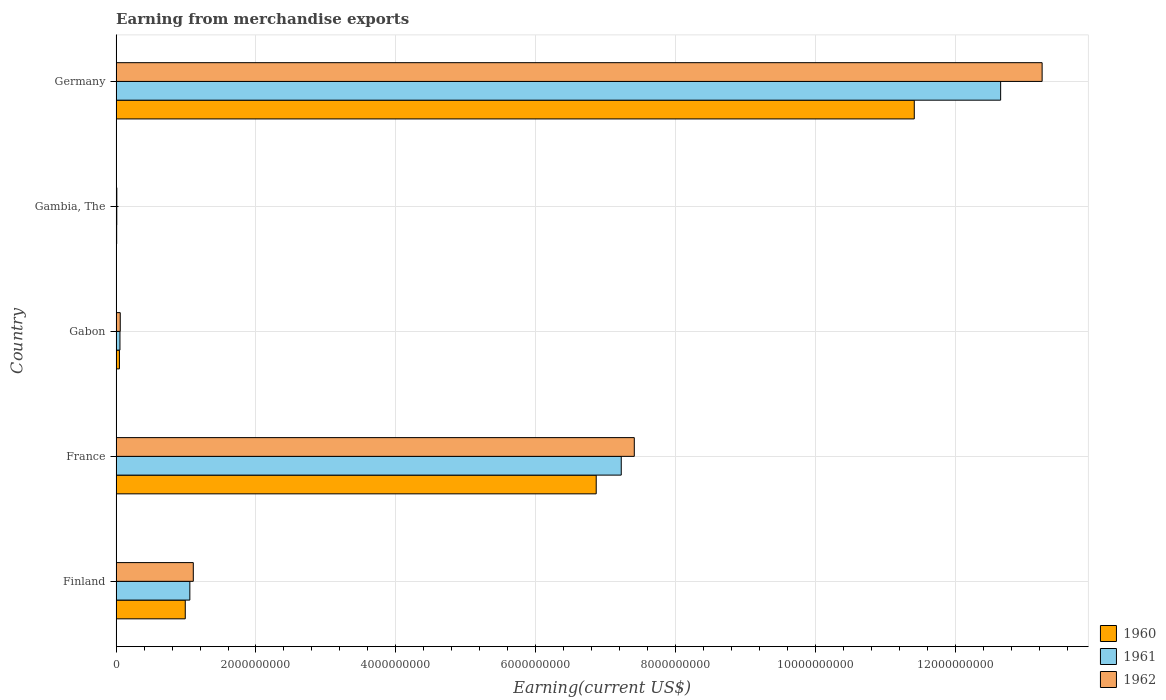What is the label of the 4th group of bars from the top?
Provide a short and direct response. France. In how many cases, is the number of bars for a given country not equal to the number of legend labels?
Ensure brevity in your answer.  0. What is the amount earned from merchandise exports in 1961 in France?
Your response must be concise. 7.22e+09. Across all countries, what is the maximum amount earned from merchandise exports in 1960?
Offer a very short reply. 1.14e+1. Across all countries, what is the minimum amount earned from merchandise exports in 1960?
Your response must be concise. 7.79e+06. In which country was the amount earned from merchandise exports in 1961 minimum?
Your answer should be compact. Gambia, The. What is the total amount earned from merchandise exports in 1961 in the graph?
Offer a terse response. 2.10e+1. What is the difference between the amount earned from merchandise exports in 1962 in Finland and that in France?
Your response must be concise. -6.31e+09. What is the difference between the amount earned from merchandise exports in 1960 in Gabon and the amount earned from merchandise exports in 1961 in Finland?
Ensure brevity in your answer.  -1.01e+09. What is the average amount earned from merchandise exports in 1961 per country?
Your answer should be very brief. 4.20e+09. What is the difference between the amount earned from merchandise exports in 1961 and amount earned from merchandise exports in 1960 in Gabon?
Provide a succinct answer. 7.33e+06. What is the ratio of the amount earned from merchandise exports in 1962 in Finland to that in Gabon?
Your response must be concise. 18.74. Is the amount earned from merchandise exports in 1961 in Gabon less than that in Germany?
Your answer should be compact. Yes. Is the difference between the amount earned from merchandise exports in 1961 in Gambia, The and Germany greater than the difference between the amount earned from merchandise exports in 1960 in Gambia, The and Germany?
Provide a short and direct response. No. What is the difference between the highest and the second highest amount earned from merchandise exports in 1961?
Provide a succinct answer. 5.43e+09. What is the difference between the highest and the lowest amount earned from merchandise exports in 1961?
Ensure brevity in your answer.  1.26e+1. In how many countries, is the amount earned from merchandise exports in 1962 greater than the average amount earned from merchandise exports in 1962 taken over all countries?
Give a very brief answer. 2. What does the 1st bar from the bottom in France represents?
Ensure brevity in your answer.  1960. Are all the bars in the graph horizontal?
Ensure brevity in your answer.  Yes. How many countries are there in the graph?
Offer a very short reply. 5. Are the values on the major ticks of X-axis written in scientific E-notation?
Make the answer very short. No. Does the graph contain grids?
Offer a very short reply. Yes. How are the legend labels stacked?
Your response must be concise. Vertical. What is the title of the graph?
Give a very brief answer. Earning from merchandise exports. Does "2005" appear as one of the legend labels in the graph?
Provide a succinct answer. No. What is the label or title of the X-axis?
Offer a terse response. Earning(current US$). What is the Earning(current US$) in 1960 in Finland?
Ensure brevity in your answer.  9.89e+08. What is the Earning(current US$) in 1961 in Finland?
Keep it short and to the point. 1.05e+09. What is the Earning(current US$) of 1962 in Finland?
Your response must be concise. 1.10e+09. What is the Earning(current US$) in 1960 in France?
Offer a very short reply. 6.87e+09. What is the Earning(current US$) in 1961 in France?
Provide a short and direct response. 7.22e+09. What is the Earning(current US$) of 1962 in France?
Offer a terse response. 7.41e+09. What is the Earning(current US$) of 1960 in Gabon?
Your answer should be compact. 4.74e+07. What is the Earning(current US$) of 1961 in Gabon?
Your answer should be compact. 5.47e+07. What is the Earning(current US$) of 1962 in Gabon?
Your response must be concise. 5.89e+07. What is the Earning(current US$) in 1960 in Gambia, The?
Your answer should be compact. 7.79e+06. What is the Earning(current US$) in 1961 in Gambia, The?
Provide a short and direct response. 9.45e+06. What is the Earning(current US$) in 1962 in Gambia, The?
Keep it short and to the point. 9.99e+06. What is the Earning(current US$) in 1960 in Germany?
Provide a succinct answer. 1.14e+1. What is the Earning(current US$) in 1961 in Germany?
Your answer should be very brief. 1.27e+1. What is the Earning(current US$) of 1962 in Germany?
Your answer should be compact. 1.32e+1. Across all countries, what is the maximum Earning(current US$) of 1960?
Offer a very short reply. 1.14e+1. Across all countries, what is the maximum Earning(current US$) of 1961?
Your answer should be very brief. 1.27e+1. Across all countries, what is the maximum Earning(current US$) of 1962?
Your answer should be very brief. 1.32e+1. Across all countries, what is the minimum Earning(current US$) of 1960?
Your answer should be very brief. 7.79e+06. Across all countries, what is the minimum Earning(current US$) of 1961?
Offer a terse response. 9.45e+06. Across all countries, what is the minimum Earning(current US$) in 1962?
Provide a succinct answer. 9.99e+06. What is the total Earning(current US$) of 1960 in the graph?
Ensure brevity in your answer.  1.93e+1. What is the total Earning(current US$) of 1961 in the graph?
Keep it short and to the point. 2.10e+1. What is the total Earning(current US$) in 1962 in the graph?
Give a very brief answer. 2.18e+1. What is the difference between the Earning(current US$) in 1960 in Finland and that in France?
Your answer should be very brief. -5.88e+09. What is the difference between the Earning(current US$) in 1961 in Finland and that in France?
Offer a very short reply. -6.17e+09. What is the difference between the Earning(current US$) of 1962 in Finland and that in France?
Ensure brevity in your answer.  -6.31e+09. What is the difference between the Earning(current US$) of 1960 in Finland and that in Gabon?
Make the answer very short. 9.41e+08. What is the difference between the Earning(current US$) of 1961 in Finland and that in Gabon?
Your answer should be very brief. 1.00e+09. What is the difference between the Earning(current US$) of 1962 in Finland and that in Gabon?
Your answer should be very brief. 1.04e+09. What is the difference between the Earning(current US$) of 1960 in Finland and that in Gambia, The?
Your answer should be compact. 9.81e+08. What is the difference between the Earning(current US$) of 1961 in Finland and that in Gambia, The?
Your answer should be very brief. 1.04e+09. What is the difference between the Earning(current US$) in 1962 in Finland and that in Gambia, The?
Ensure brevity in your answer.  1.09e+09. What is the difference between the Earning(current US$) of 1960 in Finland and that in Germany?
Give a very brief answer. -1.04e+1. What is the difference between the Earning(current US$) in 1961 in Finland and that in Germany?
Give a very brief answer. -1.16e+1. What is the difference between the Earning(current US$) in 1962 in Finland and that in Germany?
Keep it short and to the point. -1.21e+1. What is the difference between the Earning(current US$) of 1960 in France and that in Gabon?
Your response must be concise. 6.82e+09. What is the difference between the Earning(current US$) of 1961 in France and that in Gabon?
Your answer should be very brief. 7.17e+09. What is the difference between the Earning(current US$) of 1962 in France and that in Gabon?
Provide a short and direct response. 7.35e+09. What is the difference between the Earning(current US$) of 1960 in France and that in Gambia, The?
Make the answer very short. 6.86e+09. What is the difference between the Earning(current US$) in 1961 in France and that in Gambia, The?
Your answer should be compact. 7.21e+09. What is the difference between the Earning(current US$) in 1962 in France and that in Gambia, The?
Make the answer very short. 7.40e+09. What is the difference between the Earning(current US$) in 1960 in France and that in Germany?
Your answer should be compact. -4.55e+09. What is the difference between the Earning(current US$) of 1961 in France and that in Germany?
Ensure brevity in your answer.  -5.43e+09. What is the difference between the Earning(current US$) in 1962 in France and that in Germany?
Make the answer very short. -5.83e+09. What is the difference between the Earning(current US$) in 1960 in Gabon and that in Gambia, The?
Provide a short and direct response. 3.96e+07. What is the difference between the Earning(current US$) in 1961 in Gabon and that in Gambia, The?
Keep it short and to the point. 4.52e+07. What is the difference between the Earning(current US$) of 1962 in Gabon and that in Gambia, The?
Offer a terse response. 4.89e+07. What is the difference between the Earning(current US$) in 1960 in Gabon and that in Germany?
Provide a short and direct response. -1.14e+1. What is the difference between the Earning(current US$) in 1961 in Gabon and that in Germany?
Keep it short and to the point. -1.26e+1. What is the difference between the Earning(current US$) of 1962 in Gabon and that in Germany?
Make the answer very short. -1.32e+1. What is the difference between the Earning(current US$) in 1960 in Gambia, The and that in Germany?
Your response must be concise. -1.14e+1. What is the difference between the Earning(current US$) of 1961 in Gambia, The and that in Germany?
Offer a very short reply. -1.26e+1. What is the difference between the Earning(current US$) in 1962 in Gambia, The and that in Germany?
Provide a short and direct response. -1.32e+1. What is the difference between the Earning(current US$) of 1960 in Finland and the Earning(current US$) of 1961 in France?
Provide a short and direct response. -6.24e+09. What is the difference between the Earning(current US$) of 1960 in Finland and the Earning(current US$) of 1962 in France?
Provide a short and direct response. -6.42e+09. What is the difference between the Earning(current US$) in 1961 in Finland and the Earning(current US$) in 1962 in France?
Provide a short and direct response. -6.36e+09. What is the difference between the Earning(current US$) in 1960 in Finland and the Earning(current US$) in 1961 in Gabon?
Provide a short and direct response. 9.34e+08. What is the difference between the Earning(current US$) in 1960 in Finland and the Earning(current US$) in 1962 in Gabon?
Your answer should be very brief. 9.30e+08. What is the difference between the Earning(current US$) of 1961 in Finland and the Earning(current US$) of 1962 in Gabon?
Offer a terse response. 9.95e+08. What is the difference between the Earning(current US$) of 1960 in Finland and the Earning(current US$) of 1961 in Gambia, The?
Give a very brief answer. 9.79e+08. What is the difference between the Earning(current US$) of 1960 in Finland and the Earning(current US$) of 1962 in Gambia, The?
Provide a short and direct response. 9.79e+08. What is the difference between the Earning(current US$) of 1961 in Finland and the Earning(current US$) of 1962 in Gambia, The?
Ensure brevity in your answer.  1.04e+09. What is the difference between the Earning(current US$) of 1960 in Finland and the Earning(current US$) of 1961 in Germany?
Make the answer very short. -1.17e+1. What is the difference between the Earning(current US$) of 1960 in Finland and the Earning(current US$) of 1962 in Germany?
Your answer should be very brief. -1.23e+1. What is the difference between the Earning(current US$) in 1961 in Finland and the Earning(current US$) in 1962 in Germany?
Provide a succinct answer. -1.22e+1. What is the difference between the Earning(current US$) in 1960 in France and the Earning(current US$) in 1961 in Gabon?
Your answer should be very brief. 6.81e+09. What is the difference between the Earning(current US$) in 1960 in France and the Earning(current US$) in 1962 in Gabon?
Give a very brief answer. 6.81e+09. What is the difference between the Earning(current US$) in 1961 in France and the Earning(current US$) in 1962 in Gabon?
Your answer should be compact. 7.17e+09. What is the difference between the Earning(current US$) of 1960 in France and the Earning(current US$) of 1961 in Gambia, The?
Ensure brevity in your answer.  6.86e+09. What is the difference between the Earning(current US$) of 1960 in France and the Earning(current US$) of 1962 in Gambia, The?
Your response must be concise. 6.86e+09. What is the difference between the Earning(current US$) of 1961 in France and the Earning(current US$) of 1962 in Gambia, The?
Give a very brief answer. 7.21e+09. What is the difference between the Earning(current US$) of 1960 in France and the Earning(current US$) of 1961 in Germany?
Offer a terse response. -5.78e+09. What is the difference between the Earning(current US$) of 1960 in France and the Earning(current US$) of 1962 in Germany?
Your answer should be compact. -6.38e+09. What is the difference between the Earning(current US$) in 1961 in France and the Earning(current US$) in 1962 in Germany?
Provide a succinct answer. -6.02e+09. What is the difference between the Earning(current US$) in 1960 in Gabon and the Earning(current US$) in 1961 in Gambia, The?
Your response must be concise. 3.79e+07. What is the difference between the Earning(current US$) of 1960 in Gabon and the Earning(current US$) of 1962 in Gambia, The?
Provide a short and direct response. 3.74e+07. What is the difference between the Earning(current US$) of 1961 in Gabon and the Earning(current US$) of 1962 in Gambia, The?
Your answer should be very brief. 4.47e+07. What is the difference between the Earning(current US$) of 1960 in Gabon and the Earning(current US$) of 1961 in Germany?
Your answer should be compact. -1.26e+1. What is the difference between the Earning(current US$) in 1960 in Gabon and the Earning(current US$) in 1962 in Germany?
Your answer should be compact. -1.32e+1. What is the difference between the Earning(current US$) of 1961 in Gabon and the Earning(current US$) of 1962 in Germany?
Offer a very short reply. -1.32e+1. What is the difference between the Earning(current US$) in 1960 in Gambia, The and the Earning(current US$) in 1961 in Germany?
Keep it short and to the point. -1.26e+1. What is the difference between the Earning(current US$) in 1960 in Gambia, The and the Earning(current US$) in 1962 in Germany?
Make the answer very short. -1.32e+1. What is the difference between the Earning(current US$) of 1961 in Gambia, The and the Earning(current US$) of 1962 in Germany?
Your response must be concise. -1.32e+1. What is the average Earning(current US$) in 1960 per country?
Your response must be concise. 3.87e+09. What is the average Earning(current US$) of 1961 per country?
Your answer should be compact. 4.20e+09. What is the average Earning(current US$) in 1962 per country?
Your response must be concise. 4.37e+09. What is the difference between the Earning(current US$) of 1960 and Earning(current US$) of 1961 in Finland?
Provide a short and direct response. -6.56e+07. What is the difference between the Earning(current US$) of 1960 and Earning(current US$) of 1962 in Finland?
Make the answer very short. -1.15e+08. What is the difference between the Earning(current US$) of 1961 and Earning(current US$) of 1962 in Finland?
Your response must be concise. -4.94e+07. What is the difference between the Earning(current US$) of 1960 and Earning(current US$) of 1961 in France?
Provide a succinct answer. -3.58e+08. What is the difference between the Earning(current US$) of 1960 and Earning(current US$) of 1962 in France?
Your answer should be compact. -5.45e+08. What is the difference between the Earning(current US$) in 1961 and Earning(current US$) in 1962 in France?
Ensure brevity in your answer.  -1.87e+08. What is the difference between the Earning(current US$) of 1960 and Earning(current US$) of 1961 in Gabon?
Your response must be concise. -7.33e+06. What is the difference between the Earning(current US$) of 1960 and Earning(current US$) of 1962 in Gabon?
Provide a short and direct response. -1.15e+07. What is the difference between the Earning(current US$) in 1961 and Earning(current US$) in 1962 in Gabon?
Your response must be concise. -4.21e+06. What is the difference between the Earning(current US$) of 1960 and Earning(current US$) of 1961 in Gambia, The?
Give a very brief answer. -1.66e+06. What is the difference between the Earning(current US$) in 1960 and Earning(current US$) in 1962 in Gambia, The?
Your answer should be very brief. -2.20e+06. What is the difference between the Earning(current US$) in 1961 and Earning(current US$) in 1962 in Gambia, The?
Your answer should be compact. -5.43e+05. What is the difference between the Earning(current US$) of 1960 and Earning(current US$) of 1961 in Germany?
Your response must be concise. -1.24e+09. What is the difference between the Earning(current US$) in 1960 and Earning(current US$) in 1962 in Germany?
Your answer should be very brief. -1.83e+09. What is the difference between the Earning(current US$) in 1961 and Earning(current US$) in 1962 in Germany?
Your answer should be compact. -5.93e+08. What is the ratio of the Earning(current US$) of 1960 in Finland to that in France?
Keep it short and to the point. 0.14. What is the ratio of the Earning(current US$) of 1961 in Finland to that in France?
Ensure brevity in your answer.  0.15. What is the ratio of the Earning(current US$) in 1962 in Finland to that in France?
Your response must be concise. 0.15. What is the ratio of the Earning(current US$) in 1960 in Finland to that in Gabon?
Offer a terse response. 20.88. What is the ratio of the Earning(current US$) in 1961 in Finland to that in Gabon?
Provide a short and direct response. 19.28. What is the ratio of the Earning(current US$) in 1962 in Finland to that in Gabon?
Provide a succinct answer. 18.74. What is the ratio of the Earning(current US$) in 1960 in Finland to that in Gambia, The?
Provide a short and direct response. 126.93. What is the ratio of the Earning(current US$) in 1961 in Finland to that in Gambia, The?
Keep it short and to the point. 111.61. What is the ratio of the Earning(current US$) of 1962 in Finland to that in Gambia, The?
Your response must be concise. 110.48. What is the ratio of the Earning(current US$) of 1960 in Finland to that in Germany?
Offer a very short reply. 0.09. What is the ratio of the Earning(current US$) of 1961 in Finland to that in Germany?
Ensure brevity in your answer.  0.08. What is the ratio of the Earning(current US$) of 1962 in Finland to that in Germany?
Offer a terse response. 0.08. What is the ratio of the Earning(current US$) of 1960 in France to that in Gabon?
Keep it short and to the point. 145. What is the ratio of the Earning(current US$) in 1961 in France to that in Gabon?
Offer a terse response. 132.1. What is the ratio of the Earning(current US$) of 1962 in France to that in Gabon?
Give a very brief answer. 125.82. What is the ratio of the Earning(current US$) in 1960 in France to that in Gambia, The?
Keep it short and to the point. 881.48. What is the ratio of the Earning(current US$) in 1961 in France to that in Gambia, The?
Provide a succinct answer. 764.71. What is the ratio of the Earning(current US$) in 1962 in France to that in Gambia, The?
Provide a short and direct response. 741.82. What is the ratio of the Earning(current US$) in 1960 in France to that in Germany?
Ensure brevity in your answer.  0.6. What is the ratio of the Earning(current US$) in 1961 in France to that in Germany?
Give a very brief answer. 0.57. What is the ratio of the Earning(current US$) of 1962 in France to that in Germany?
Keep it short and to the point. 0.56. What is the ratio of the Earning(current US$) of 1960 in Gabon to that in Gambia, The?
Provide a short and direct response. 6.08. What is the ratio of the Earning(current US$) in 1961 in Gabon to that in Gambia, The?
Provide a short and direct response. 5.79. What is the ratio of the Earning(current US$) in 1962 in Gabon to that in Gambia, The?
Your answer should be very brief. 5.9. What is the ratio of the Earning(current US$) of 1960 in Gabon to that in Germany?
Keep it short and to the point. 0. What is the ratio of the Earning(current US$) in 1961 in Gabon to that in Germany?
Provide a succinct answer. 0. What is the ratio of the Earning(current US$) in 1962 in Gabon to that in Germany?
Your response must be concise. 0. What is the ratio of the Earning(current US$) of 1960 in Gambia, The to that in Germany?
Your answer should be compact. 0. What is the ratio of the Earning(current US$) of 1961 in Gambia, The to that in Germany?
Your answer should be very brief. 0. What is the ratio of the Earning(current US$) in 1962 in Gambia, The to that in Germany?
Provide a short and direct response. 0. What is the difference between the highest and the second highest Earning(current US$) in 1960?
Offer a very short reply. 4.55e+09. What is the difference between the highest and the second highest Earning(current US$) in 1961?
Offer a terse response. 5.43e+09. What is the difference between the highest and the second highest Earning(current US$) of 1962?
Offer a very short reply. 5.83e+09. What is the difference between the highest and the lowest Earning(current US$) in 1960?
Your answer should be very brief. 1.14e+1. What is the difference between the highest and the lowest Earning(current US$) of 1961?
Your answer should be compact. 1.26e+1. What is the difference between the highest and the lowest Earning(current US$) in 1962?
Ensure brevity in your answer.  1.32e+1. 